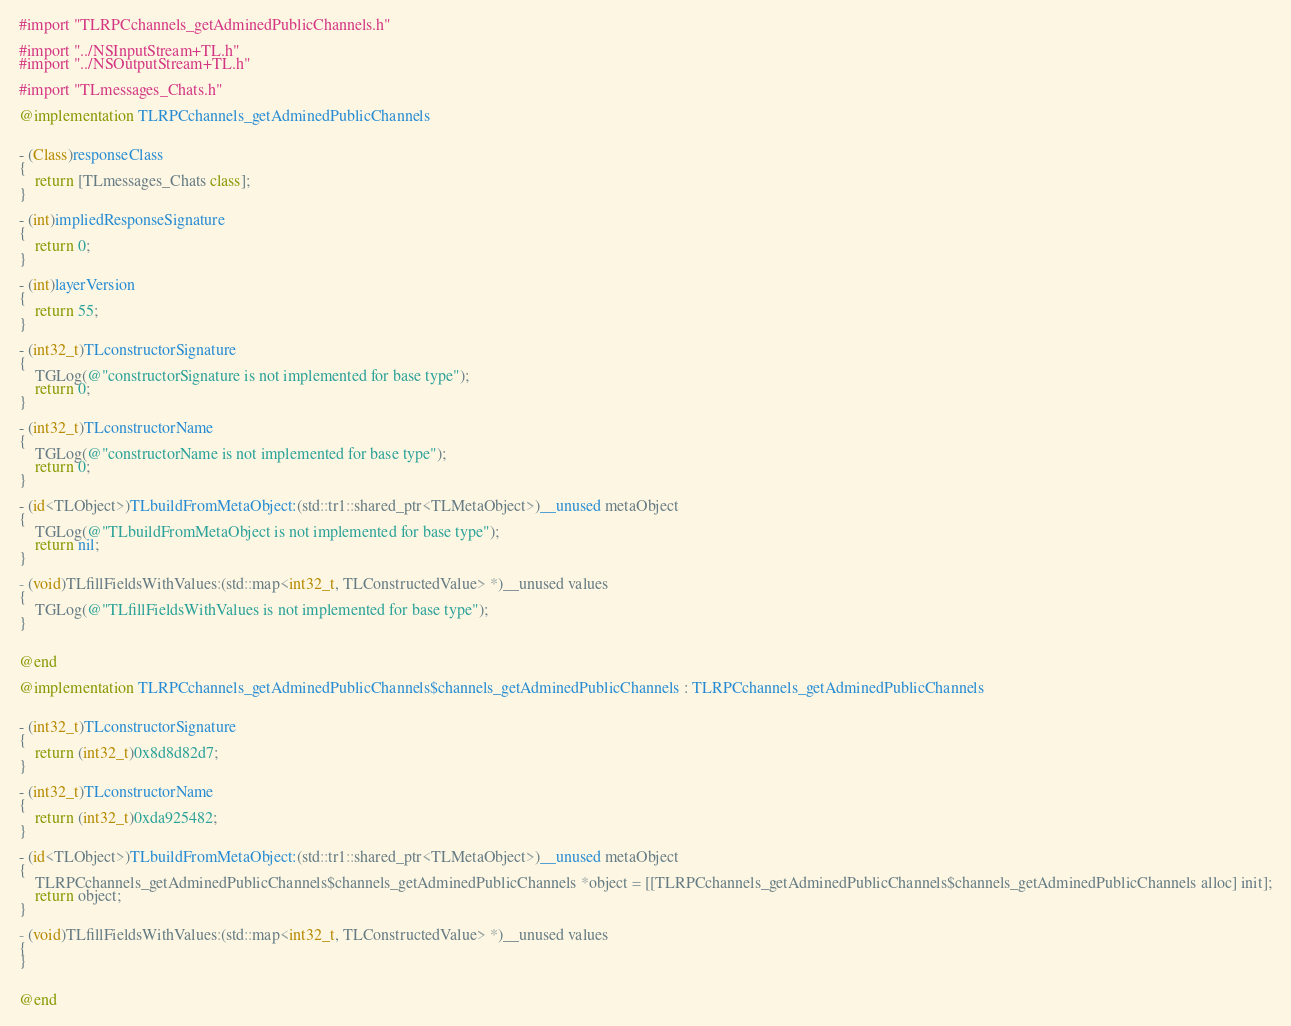<code> <loc_0><loc_0><loc_500><loc_500><_ObjectiveC_>#import "TLRPCchannels_getAdminedPublicChannels.h"

#import "../NSInputStream+TL.h"
#import "../NSOutputStream+TL.h"

#import "TLmessages_Chats.h"

@implementation TLRPCchannels_getAdminedPublicChannels


- (Class)responseClass
{
    return [TLmessages_Chats class];
}

- (int)impliedResponseSignature
{
    return 0;
}

- (int)layerVersion
{
    return 55;
}

- (int32_t)TLconstructorSignature
{
    TGLog(@"constructorSignature is not implemented for base type");
    return 0;
}

- (int32_t)TLconstructorName
{
    TGLog(@"constructorName is not implemented for base type");
    return 0;
}

- (id<TLObject>)TLbuildFromMetaObject:(std::tr1::shared_ptr<TLMetaObject>)__unused metaObject
{
    TGLog(@"TLbuildFromMetaObject is not implemented for base type");
    return nil;
}

- (void)TLfillFieldsWithValues:(std::map<int32_t, TLConstructedValue> *)__unused values
{
    TGLog(@"TLfillFieldsWithValues is not implemented for base type");
}


@end

@implementation TLRPCchannels_getAdminedPublicChannels$channels_getAdminedPublicChannels : TLRPCchannels_getAdminedPublicChannels


- (int32_t)TLconstructorSignature
{
    return (int32_t)0x8d8d82d7;
}

- (int32_t)TLconstructorName
{
    return (int32_t)0xda925482;
}

- (id<TLObject>)TLbuildFromMetaObject:(std::tr1::shared_ptr<TLMetaObject>)__unused metaObject
{
    TLRPCchannels_getAdminedPublicChannels$channels_getAdminedPublicChannels *object = [[TLRPCchannels_getAdminedPublicChannels$channels_getAdminedPublicChannels alloc] init];
    return object;
}

- (void)TLfillFieldsWithValues:(std::map<int32_t, TLConstructedValue> *)__unused values
{
}


@end

</code> 